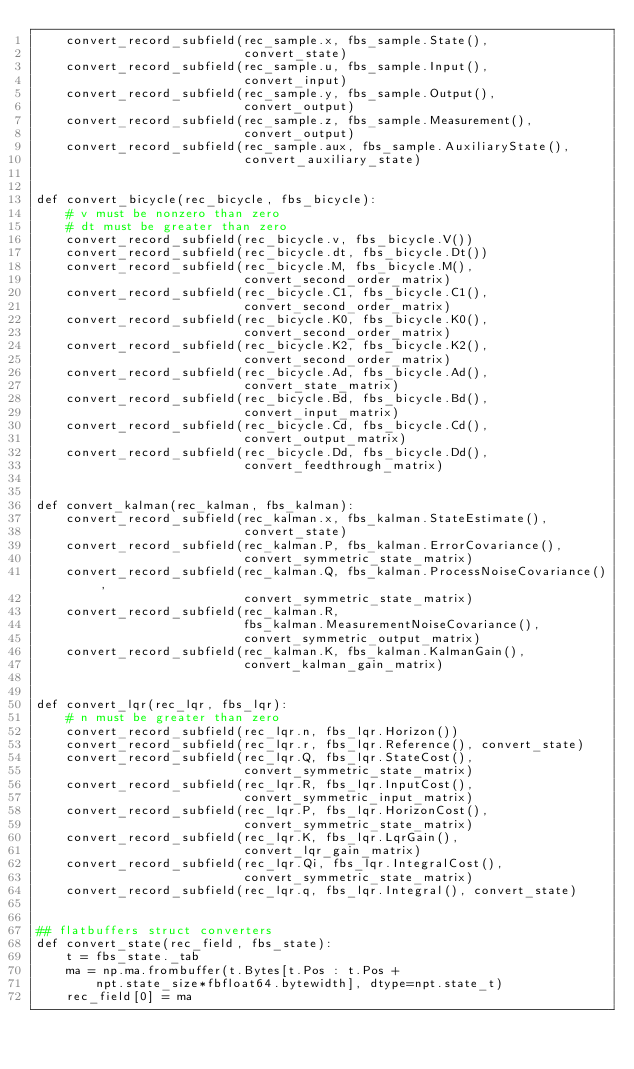<code> <loc_0><loc_0><loc_500><loc_500><_Python_>    convert_record_subfield(rec_sample.x, fbs_sample.State(),
                            convert_state)
    convert_record_subfield(rec_sample.u, fbs_sample.Input(),
                            convert_input)
    convert_record_subfield(rec_sample.y, fbs_sample.Output(),
                            convert_output)
    convert_record_subfield(rec_sample.z, fbs_sample.Measurement(),
                            convert_output)
    convert_record_subfield(rec_sample.aux, fbs_sample.AuxiliaryState(),
                            convert_auxiliary_state)


def convert_bicycle(rec_bicycle, fbs_bicycle):
    # v must be nonzero than zero
    # dt must be greater than zero
    convert_record_subfield(rec_bicycle.v, fbs_bicycle.V())
    convert_record_subfield(rec_bicycle.dt, fbs_bicycle.Dt())
    convert_record_subfield(rec_bicycle.M, fbs_bicycle.M(),
                            convert_second_order_matrix)
    convert_record_subfield(rec_bicycle.C1, fbs_bicycle.C1(),
                            convert_second_order_matrix)
    convert_record_subfield(rec_bicycle.K0, fbs_bicycle.K0(),
                            convert_second_order_matrix)
    convert_record_subfield(rec_bicycle.K2, fbs_bicycle.K2(),
                            convert_second_order_matrix)
    convert_record_subfield(rec_bicycle.Ad, fbs_bicycle.Ad(),
                            convert_state_matrix)
    convert_record_subfield(rec_bicycle.Bd, fbs_bicycle.Bd(),
                            convert_input_matrix)
    convert_record_subfield(rec_bicycle.Cd, fbs_bicycle.Cd(),
                            convert_output_matrix)
    convert_record_subfield(rec_bicycle.Dd, fbs_bicycle.Dd(),
                            convert_feedthrough_matrix)


def convert_kalman(rec_kalman, fbs_kalman):
    convert_record_subfield(rec_kalman.x, fbs_kalman.StateEstimate(),
                            convert_state)
    convert_record_subfield(rec_kalman.P, fbs_kalman.ErrorCovariance(),
                            convert_symmetric_state_matrix)
    convert_record_subfield(rec_kalman.Q, fbs_kalman.ProcessNoiseCovariance(),
                            convert_symmetric_state_matrix)
    convert_record_subfield(rec_kalman.R,
                            fbs_kalman.MeasurementNoiseCovariance(),
                            convert_symmetric_output_matrix)
    convert_record_subfield(rec_kalman.K, fbs_kalman.KalmanGain(),
                            convert_kalman_gain_matrix)


def convert_lqr(rec_lqr, fbs_lqr):
    # n must be greater than zero
    convert_record_subfield(rec_lqr.n, fbs_lqr.Horizon())
    convert_record_subfield(rec_lqr.r, fbs_lqr.Reference(), convert_state)
    convert_record_subfield(rec_lqr.Q, fbs_lqr.StateCost(),
                            convert_symmetric_state_matrix)
    convert_record_subfield(rec_lqr.R, fbs_lqr.InputCost(),
                            convert_symmetric_input_matrix)
    convert_record_subfield(rec_lqr.P, fbs_lqr.HorizonCost(),
                            convert_symmetric_state_matrix)
    convert_record_subfield(rec_lqr.K, fbs_lqr.LqrGain(),
                            convert_lqr_gain_matrix)
    convert_record_subfield(rec_lqr.Qi, fbs_lqr.IntegralCost(),
                            convert_symmetric_state_matrix)
    convert_record_subfield(rec_lqr.q, fbs_lqr.Integral(), convert_state)


## flatbuffers struct converters
def convert_state(rec_field, fbs_state):
    t = fbs_state._tab
    ma = np.ma.frombuffer(t.Bytes[t.Pos : t.Pos +
        npt.state_size*fbfloat64.bytewidth], dtype=npt.state_t)
    rec_field[0] = ma

</code> 